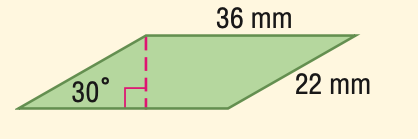Answer the mathemtical geometry problem and directly provide the correct option letter.
Question: Find the perimeter of the parallelogram.
Choices: A: 58 B: 72 C: 88 D: 116 D 